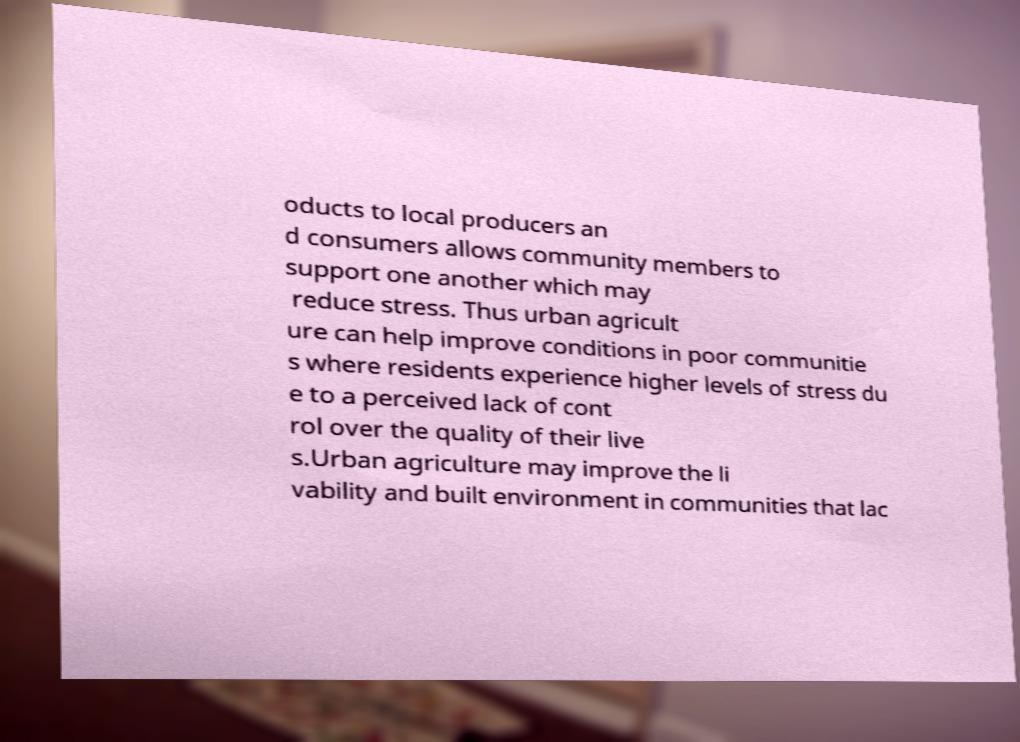What messages or text are displayed in this image? I need them in a readable, typed format. oducts to local producers an d consumers allows community members to support one another which may reduce stress. Thus urban agricult ure can help improve conditions in poor communitie s where residents experience higher levels of stress du e to a perceived lack of cont rol over the quality of their live s.Urban agriculture may improve the li vability and built environment in communities that lac 